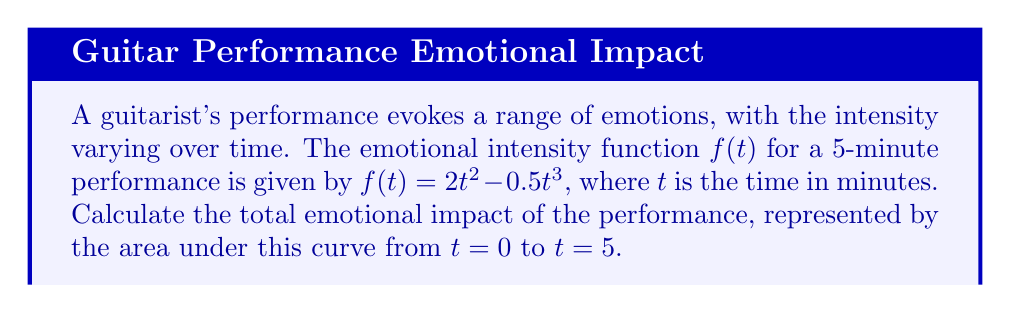Provide a solution to this math problem. To find the area under the curve, we need to integrate the function $f(t) = 2t^2 - 0.5t^3$ from $t=0$ to $t=5$. This process can be seen as summing up all the emotional intensities over the duration of the performance, much like how a poet might weave together various literary devices to create a cumulative effect.

Let's approach this step-by-step:

1) We need to evaluate the definite integral:

   $$\int_0^5 (2t^2 - 0.5t^3) dt$$

2) Integrate each term separately:
   
   For $2t^2$: $\int 2t^2 dt = \frac{2t^3}{3}$
   For $-0.5t^3$: $\int -0.5t^3 dt = -\frac{0.5t^4}{4} = -\frac{t^4}{8}$

3) Apply the fundamental theorem of calculus:

   $$\left[\frac{2t^3}{3} - \frac{t^4}{8}\right]_0^5$$

4) Evaluate at the upper and lower bounds:

   $$\left(\frac{2(5^3)}{3} - \frac{5^4}{8}\right) - \left(\frac{2(0^3)}{3} - \frac{0^4}{8}\right)$$

5) Simplify:

   $$\left(\frac{250}{3} - \frac{625}{8}\right) - (0 - 0)$$

6) Calculate:

   $$\frac{2000}{24} - \frac{1875}{24} = \frac{125}{24}$$

This result, $\frac{125}{24}$, represents the total emotional impact of the performance, akin to the overall impression left by a carefully crafted poem or song lyric.
Answer: $\frac{125}{24}$ or approximately $5.21$ 